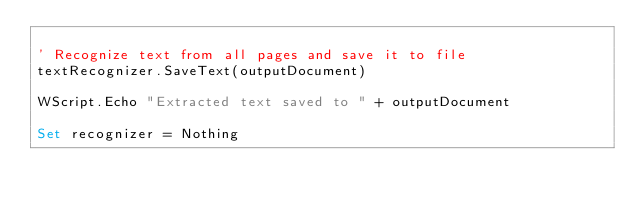<code> <loc_0><loc_0><loc_500><loc_500><_VisualBasic_>
' Recognize text from all pages and save it to file
textRecognizer.SaveText(outputDocument)

WScript.Echo "Extracted text saved to " + outputDocument

Set recognizer = Nothing

</code> 